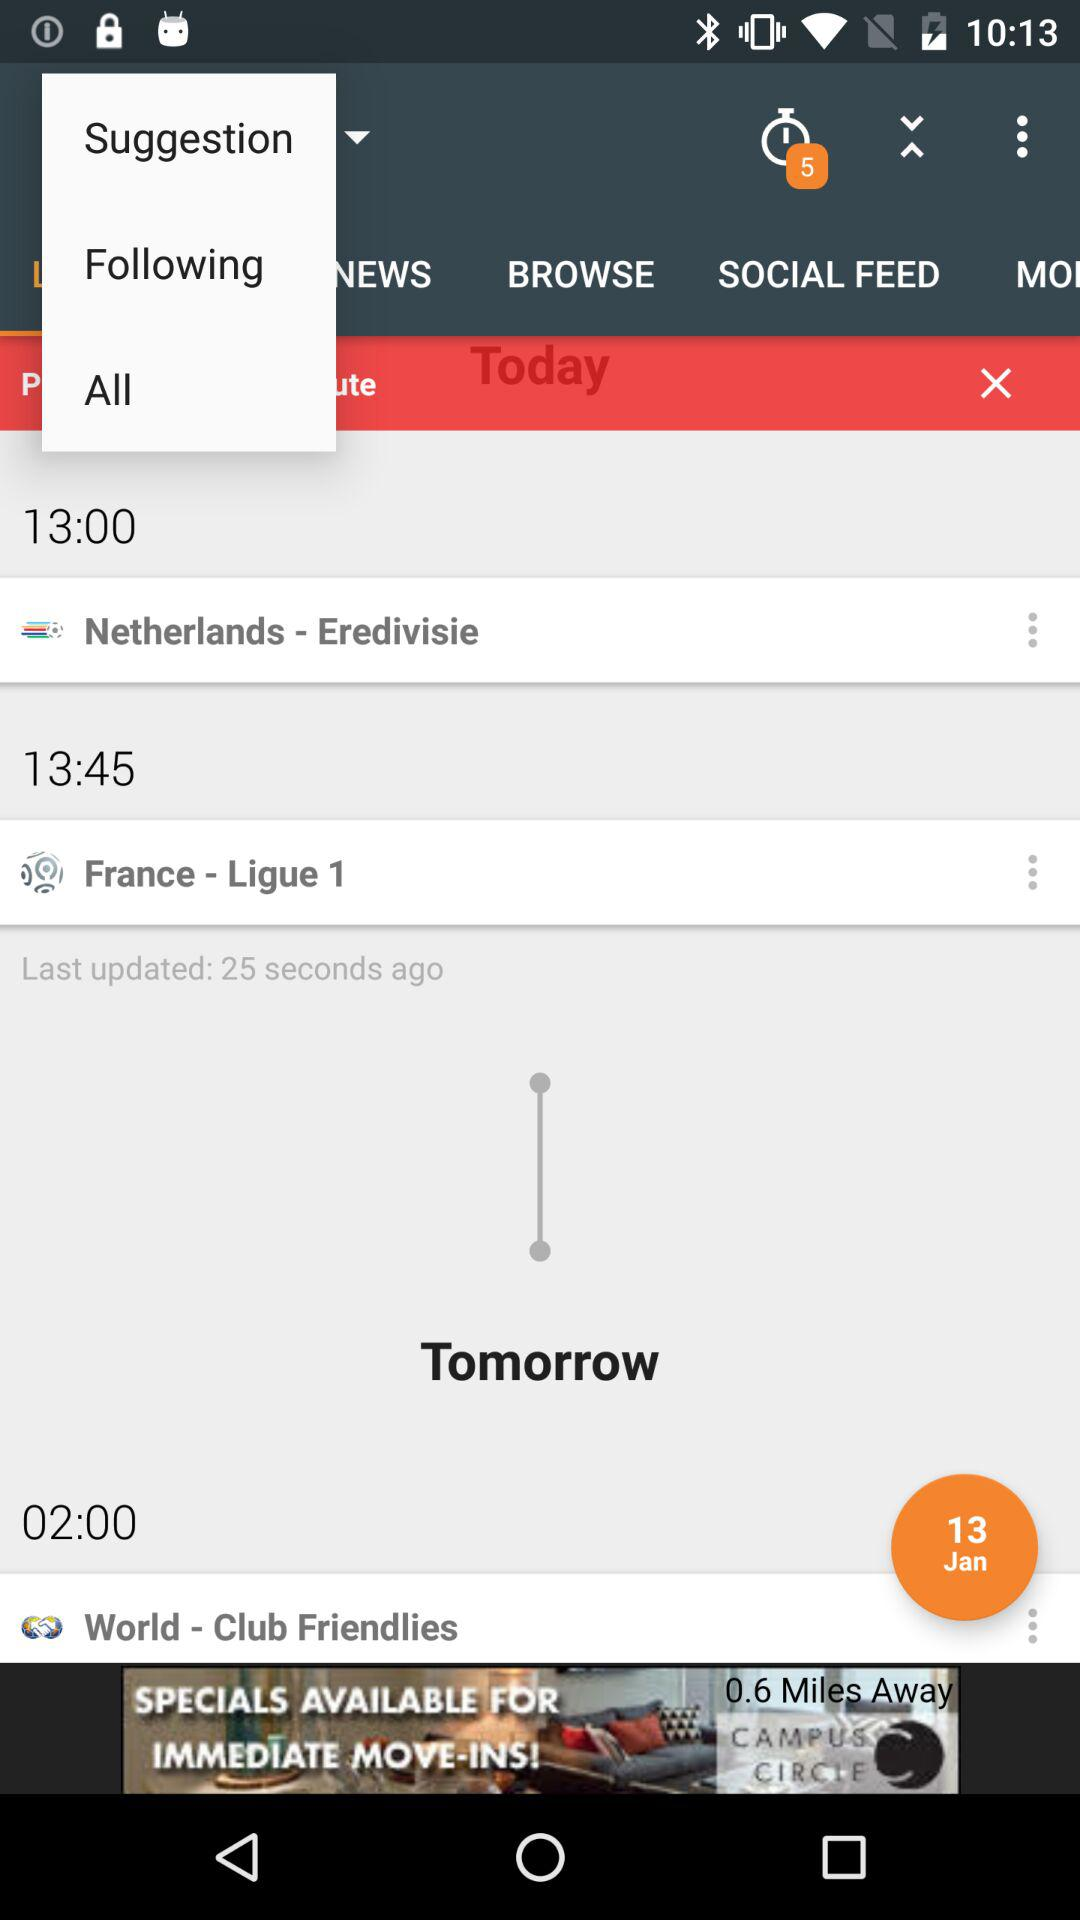What is the date? The date is 13th January. 